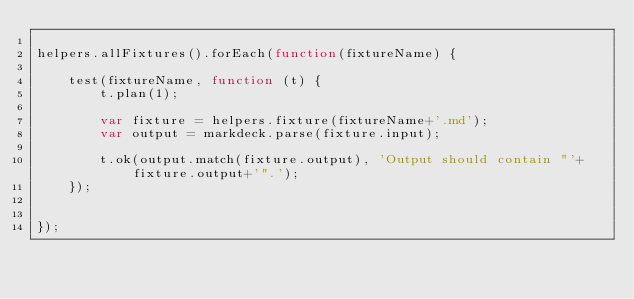Convert code to text. <code><loc_0><loc_0><loc_500><loc_500><_JavaScript_>
helpers.allFixtures().forEach(function(fixtureName) {

    test(fixtureName, function (t) {
        t.plan(1);

        var fixture = helpers.fixture(fixtureName+'.md');
        var output = markdeck.parse(fixture.input);

        t.ok(output.match(fixture.output), 'Output should contain "'+fixture.output+'".');
    });


});

</code> 